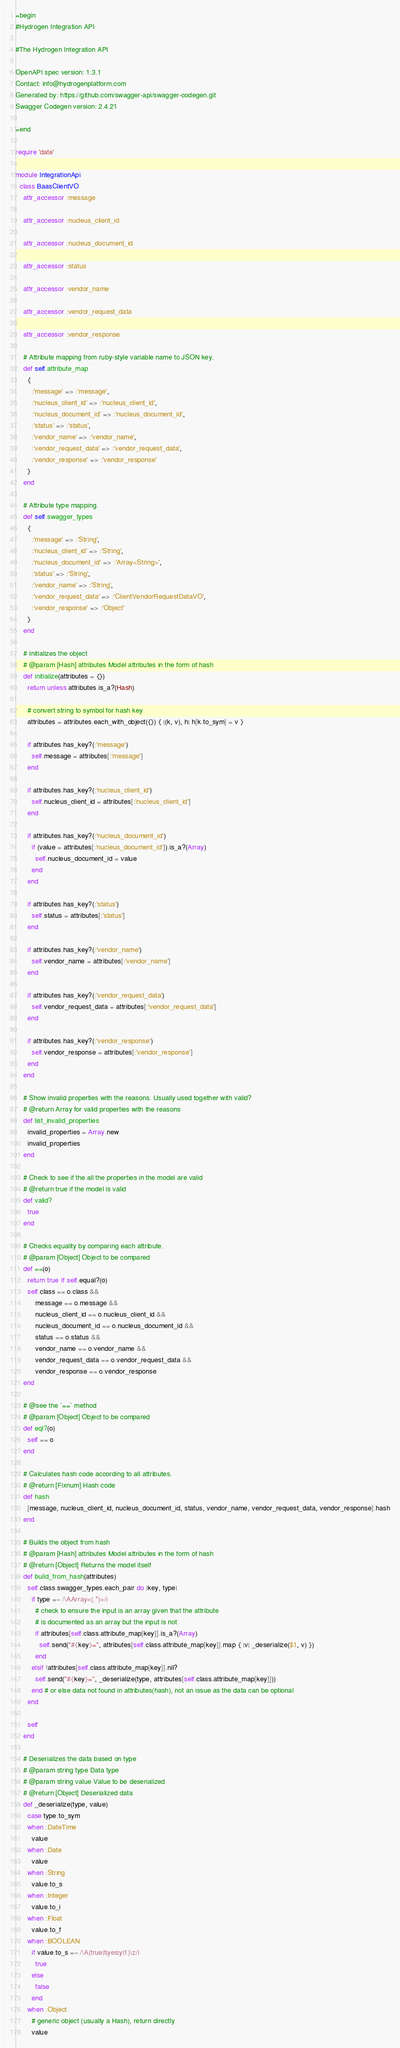<code> <loc_0><loc_0><loc_500><loc_500><_Ruby_>=begin
#Hydrogen Integration API

#The Hydrogen Integration API

OpenAPI spec version: 1.3.1
Contact: info@hydrogenplatform.com
Generated by: https://github.com/swagger-api/swagger-codegen.git
Swagger Codegen version: 2.4.21

=end

require 'date'

module IntegrationApi
  class BaasClientVO
    attr_accessor :message

    attr_accessor :nucleus_client_id

    attr_accessor :nucleus_document_id

    attr_accessor :status

    attr_accessor :vendor_name

    attr_accessor :vendor_request_data

    attr_accessor :vendor_response

    # Attribute mapping from ruby-style variable name to JSON key.
    def self.attribute_map
      {
        :'message' => :'message',
        :'nucleus_client_id' => :'nucleus_client_id',
        :'nucleus_document_id' => :'nucleus_document_id',
        :'status' => :'status',
        :'vendor_name' => :'vendor_name',
        :'vendor_request_data' => :'vendor_request_data',
        :'vendor_response' => :'vendor_response'
      }
    end

    # Attribute type mapping.
    def self.swagger_types
      {
        :'message' => :'String',
        :'nucleus_client_id' => :'String',
        :'nucleus_document_id' => :'Array<String>',
        :'status' => :'String',
        :'vendor_name' => :'String',
        :'vendor_request_data' => :'ClientVendorRequestDataVO',
        :'vendor_response' => :'Object'
      }
    end

    # Initializes the object
    # @param [Hash] attributes Model attributes in the form of hash
    def initialize(attributes = {})
      return unless attributes.is_a?(Hash)

      # convert string to symbol for hash key
      attributes = attributes.each_with_object({}) { |(k, v), h| h[k.to_sym] = v }

      if attributes.has_key?(:'message')
        self.message = attributes[:'message']
      end

      if attributes.has_key?(:'nucleus_client_id')
        self.nucleus_client_id = attributes[:'nucleus_client_id']
      end

      if attributes.has_key?(:'nucleus_document_id')
        if (value = attributes[:'nucleus_document_id']).is_a?(Array)
          self.nucleus_document_id = value
        end
      end

      if attributes.has_key?(:'status')
        self.status = attributes[:'status']
      end

      if attributes.has_key?(:'vendor_name')
        self.vendor_name = attributes[:'vendor_name']
      end

      if attributes.has_key?(:'vendor_request_data')
        self.vendor_request_data = attributes[:'vendor_request_data']
      end

      if attributes.has_key?(:'vendor_response')
        self.vendor_response = attributes[:'vendor_response']
      end
    end

    # Show invalid properties with the reasons. Usually used together with valid?
    # @return Array for valid properties with the reasons
    def list_invalid_properties
      invalid_properties = Array.new
      invalid_properties
    end

    # Check to see if the all the properties in the model are valid
    # @return true if the model is valid
    def valid?
      true
    end

    # Checks equality by comparing each attribute.
    # @param [Object] Object to be compared
    def ==(o)
      return true if self.equal?(o)
      self.class == o.class &&
          message == o.message &&
          nucleus_client_id == o.nucleus_client_id &&
          nucleus_document_id == o.nucleus_document_id &&
          status == o.status &&
          vendor_name == o.vendor_name &&
          vendor_request_data == o.vendor_request_data &&
          vendor_response == o.vendor_response
    end

    # @see the `==` method
    # @param [Object] Object to be compared
    def eql?(o)
      self == o
    end

    # Calculates hash code according to all attributes.
    # @return [Fixnum] Hash code
    def hash
      [message, nucleus_client_id, nucleus_document_id, status, vendor_name, vendor_request_data, vendor_response].hash
    end

    # Builds the object from hash
    # @param [Hash] attributes Model attributes in the form of hash
    # @return [Object] Returns the model itself
    def build_from_hash(attributes)
      self.class.swagger_types.each_pair do |key, type|
        if type =~ /\AArray<(.*)>/i
          # check to ensure the input is an array given that the attribute
          # is documented as an array but the input is not
          if attributes[self.class.attribute_map[key]].is_a?(Array)
            self.send("#{key}=", attributes[self.class.attribute_map[key]].map { |v| _deserialize($1, v) })
          end
        elsif !attributes[self.class.attribute_map[key]].nil?
          self.send("#{key}=", _deserialize(type, attributes[self.class.attribute_map[key]]))
        end # or else data not found in attributes(hash), not an issue as the data can be optional
      end

      self
    end

    # Deserializes the data based on type
    # @param string type Data type
    # @param string value Value to be deserialized
    # @return [Object] Deserialized data
    def _deserialize(type, value)
      case type.to_sym
      when :DateTime
        value
      when :Date
        value
      when :String
        value.to_s
      when :Integer
        value.to_i
      when :Float
        value.to_f
      when :BOOLEAN
        if value.to_s =~ /\A(true|t|yes|y|1)\z/i
          true
        else
          false
        end
      when :Object
        # generic object (usually a Hash), return directly
        value</code> 